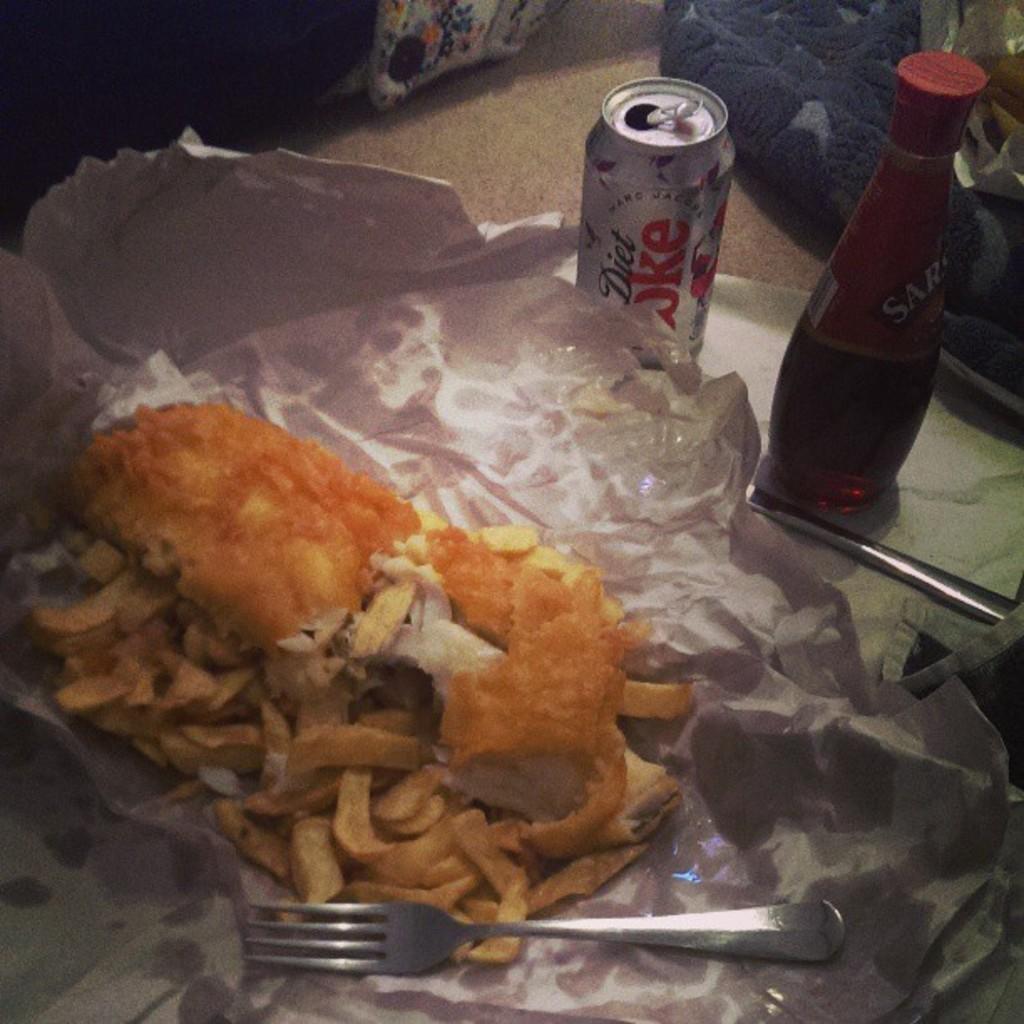Is this soda diet?
Your answer should be very brief. Yes. 